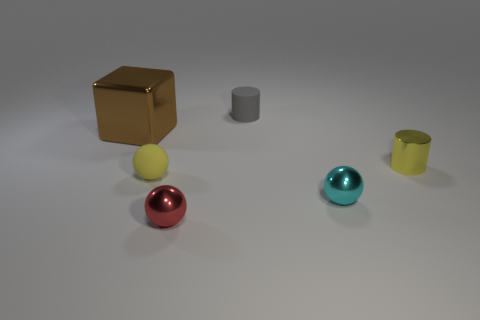Subtract 1 brown blocks. How many objects are left? 5 Subtract all cubes. How many objects are left? 5 Subtract 2 spheres. How many spheres are left? 1 Subtract all blue balls. Subtract all gray blocks. How many balls are left? 3 Subtract all red cubes. How many brown spheres are left? 0 Subtract all big brown blocks. Subtract all big shiny blocks. How many objects are left? 4 Add 1 tiny yellow shiny objects. How many tiny yellow shiny objects are left? 2 Add 3 gray matte cubes. How many gray matte cubes exist? 3 Add 1 small matte objects. How many objects exist? 7 Subtract all red spheres. How many spheres are left? 2 